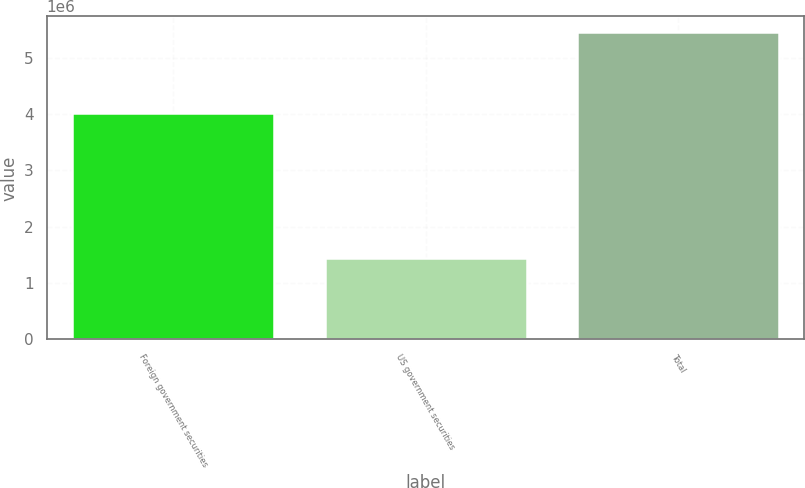<chart> <loc_0><loc_0><loc_500><loc_500><bar_chart><fcel>Foreign government securities<fcel>US government securities<fcel>Total<nl><fcel>4.01941e+06<fcel>1.44331e+06<fcel>5.46272e+06<nl></chart> 